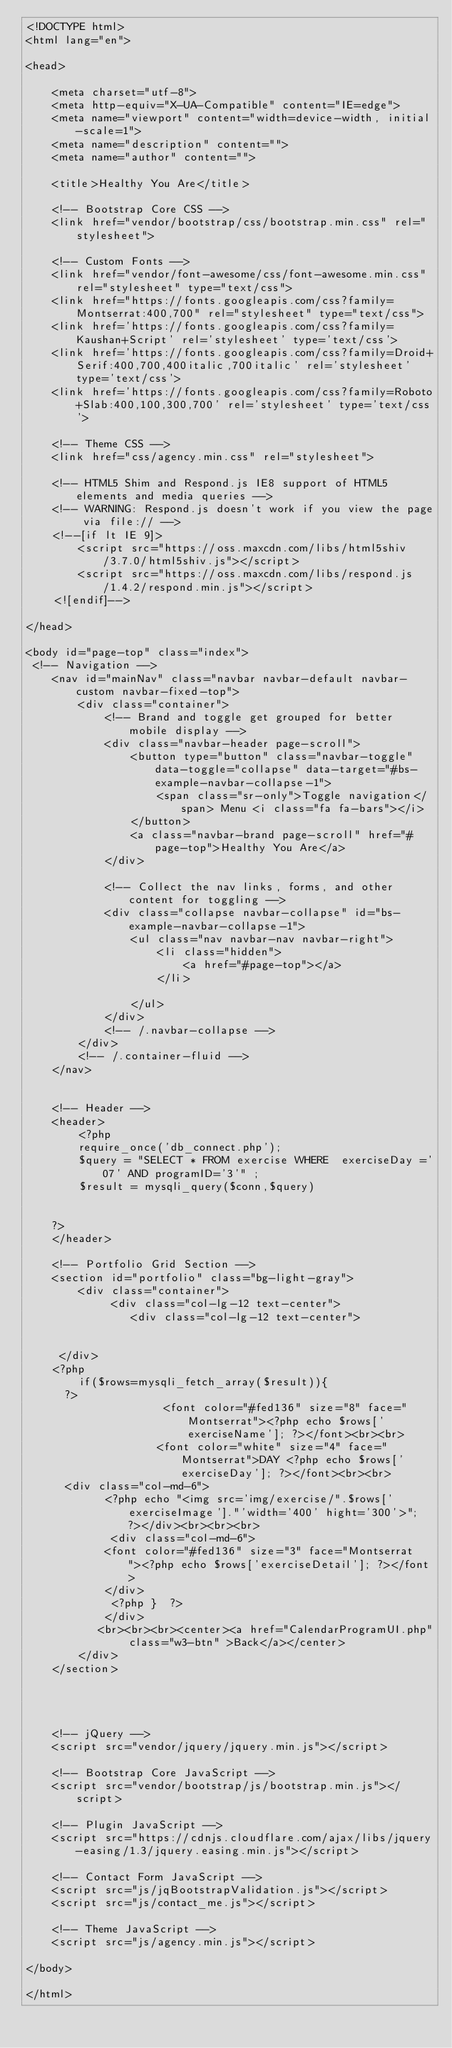Convert code to text. <code><loc_0><loc_0><loc_500><loc_500><_PHP_><!DOCTYPE html>
<html lang="en">

<head>

    <meta charset="utf-8">
    <meta http-equiv="X-UA-Compatible" content="IE=edge">
    <meta name="viewport" content="width=device-width, initial-scale=1">
    <meta name="description" content="">
    <meta name="author" content="">

    <title>Healthy You Are</title>

    <!-- Bootstrap Core CSS -->
    <link href="vendor/bootstrap/css/bootstrap.min.css" rel="stylesheet">

    <!-- Custom Fonts -->
    <link href="vendor/font-awesome/css/font-awesome.min.css" rel="stylesheet" type="text/css">
    <link href="https://fonts.googleapis.com/css?family=Montserrat:400,700" rel="stylesheet" type="text/css">
    <link href='https://fonts.googleapis.com/css?family=Kaushan+Script' rel='stylesheet' type='text/css'>
    <link href='https://fonts.googleapis.com/css?family=Droid+Serif:400,700,400italic,700italic' rel='stylesheet' type='text/css'>
    <link href='https://fonts.googleapis.com/css?family=Roboto+Slab:400,100,300,700' rel='stylesheet' type='text/css'>

    <!-- Theme CSS -->
    <link href="css/agency.min.css" rel="stylesheet">

    <!-- HTML5 Shim and Respond.js IE8 support of HTML5 elements and media queries -->
    <!-- WARNING: Respond.js doesn't work if you view the page via file:// -->
    <!--[if lt IE 9]>
        <script src="https://oss.maxcdn.com/libs/html5shiv/3.7.0/html5shiv.js"></script>
        <script src="https://oss.maxcdn.com/libs/respond.js/1.4.2/respond.min.js"></script>
    <![endif]-->

</head>

<body id="page-top" class="index">
 <!-- Navigation -->
    <nav id="mainNav" class="navbar navbar-default navbar-custom navbar-fixed-top">
        <div class="container">
            <!-- Brand and toggle get grouped for better mobile display -->
            <div class="navbar-header page-scroll">
                <button type="button" class="navbar-toggle" data-toggle="collapse" data-target="#bs-example-navbar-collapse-1">
                    <span class="sr-only">Toggle navigation</span> Menu <i class="fa fa-bars"></i>
                </button>
                <a class="navbar-brand page-scroll" href="#page-top">Healthy You Are</a>
            </div>

            <!-- Collect the nav links, forms, and other content for toggling -->
            <div class="collapse navbar-collapse" id="bs-example-navbar-collapse-1">
                <ul class="nav navbar-nav navbar-right">
                    <li class="hidden">
                        <a href="#page-top"></a>
                    </li>
                
                </ul>
            </div>
            <!-- /.navbar-collapse -->
        </div>
        <!-- /.container-fluid -->
    </nav>
    

    <!-- Header -->
    <header>
        <?php
        require_once('db_connect.php');
        $query = "SELECT * FROM exercise WHERE  exerciseDay ='07' AND programID='3'" ;
        $result = mysqli_query($conn,$query)
       
        
    ?>
    </header>

    <!-- Portfolio Grid Section -->
    <section id="portfolio" class="bg-light-gray">
        <div class="container">
             <div class="col-lg-12 text-center">
                <div class="col-lg-12 text-center">
                  
                    
     </div>
    <?php 
        if($rows=mysqli_fetch_array($result)){ 
      ?>  
                     <font color="#fed136" size="8" face="Montserrat"><?php echo $rows['exerciseName']; ?></font><br><br>
                    <font color="white" size="4" face="Montserrat">DAY <?php echo $rows['exerciseDay']; ?></font><br><br>
      <div class="col-md-6">
            <?php echo "<img src='img/exercise/".$rows['exerciseImage']."'width='400' hight='300'>"; ?></div><br><br><br>
             <div class="col-md-6">
            <font color="#fed136" size="3" face="Montserrat"><?php echo $rows['exerciseDetail']; ?></font>
            </div>
             <?php }  ?>
            </div>
           <br><br><br><center><a href="CalendarProgramUI.php" class="w3-btn" >Back</a></center>
        </div>
    </section>


 

    <!-- jQuery -->
    <script src="vendor/jquery/jquery.min.js"></script>

    <!-- Bootstrap Core JavaScript -->
    <script src="vendor/bootstrap/js/bootstrap.min.js"></script>

    <!-- Plugin JavaScript -->
    <script src="https://cdnjs.cloudflare.com/ajax/libs/jquery-easing/1.3/jquery.easing.min.js"></script>

    <!-- Contact Form JavaScript -->
    <script src="js/jqBootstrapValidation.js"></script>
    <script src="js/contact_me.js"></script>

    <!-- Theme JavaScript -->
    <script src="js/agency.min.js"></script>

</body>

</html>
</code> 